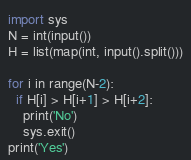Convert code to text. <code><loc_0><loc_0><loc_500><loc_500><_Python_>import sys
N = int(input())
H = list(map(int, input().split()))

for i in range(N-2):
  if H[i] > H[i+1] > H[i+2]:
    print('No')
    sys.exit()
print('Yes')</code> 